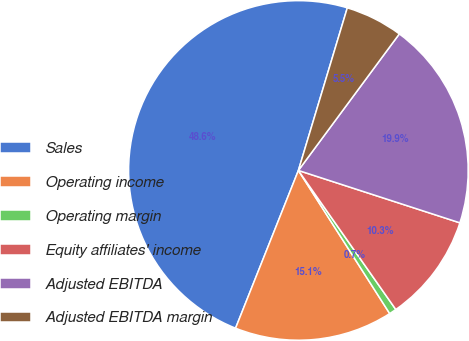<chart> <loc_0><loc_0><loc_500><loc_500><pie_chart><fcel>Sales<fcel>Operating income<fcel>Operating margin<fcel>Equity affiliates' income<fcel>Adjusted EBITDA<fcel>Adjusted EBITDA margin<nl><fcel>48.62%<fcel>15.07%<fcel>0.69%<fcel>10.28%<fcel>19.86%<fcel>5.48%<nl></chart> 